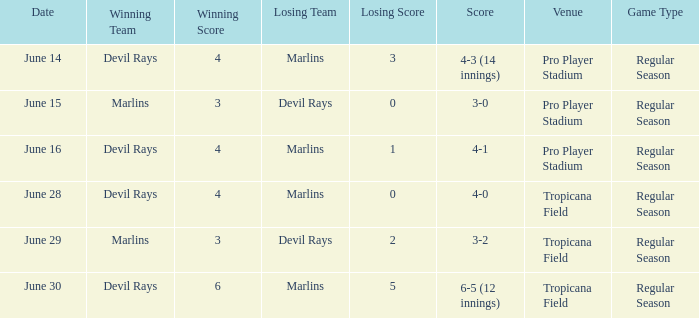What was the result on june 29? 3-2. 